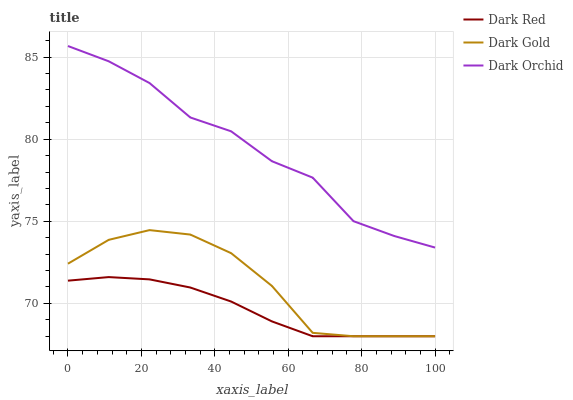Does Dark Red have the minimum area under the curve?
Answer yes or no. Yes. Does Dark Orchid have the maximum area under the curve?
Answer yes or no. Yes. Does Dark Gold have the minimum area under the curve?
Answer yes or no. No. Does Dark Gold have the maximum area under the curve?
Answer yes or no. No. Is Dark Red the smoothest?
Answer yes or no. Yes. Is Dark Orchid the roughest?
Answer yes or no. Yes. Is Dark Gold the smoothest?
Answer yes or no. No. Is Dark Gold the roughest?
Answer yes or no. No. Does Dark Red have the lowest value?
Answer yes or no. Yes. Does Dark Orchid have the lowest value?
Answer yes or no. No. Does Dark Orchid have the highest value?
Answer yes or no. Yes. Does Dark Gold have the highest value?
Answer yes or no. No. Is Dark Red less than Dark Orchid?
Answer yes or no. Yes. Is Dark Orchid greater than Dark Gold?
Answer yes or no. Yes. Does Dark Gold intersect Dark Red?
Answer yes or no. Yes. Is Dark Gold less than Dark Red?
Answer yes or no. No. Is Dark Gold greater than Dark Red?
Answer yes or no. No. Does Dark Red intersect Dark Orchid?
Answer yes or no. No. 